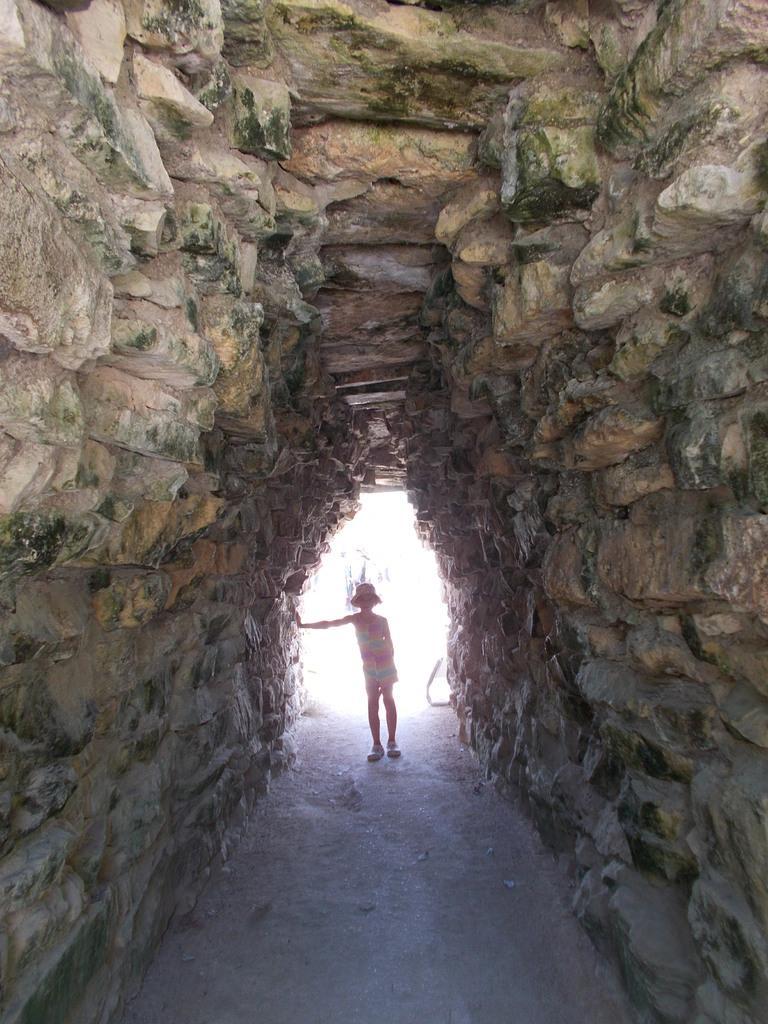Could you give a brief overview of what you see in this image? Here we can see a girl standing on the ground in a cave and she wore a hat on her head. 